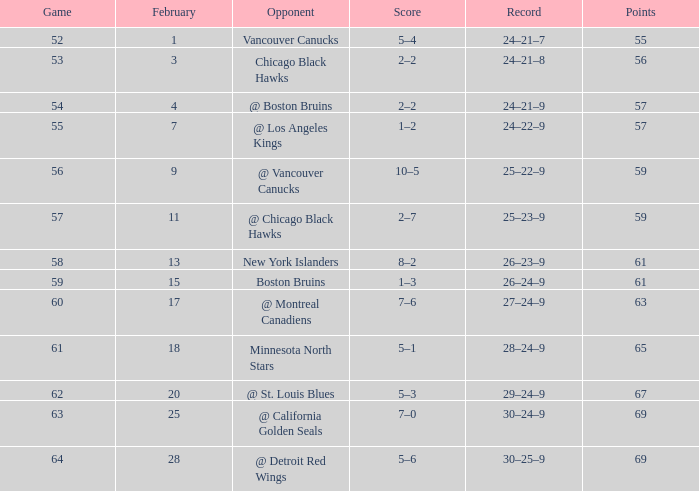How many games in february had a 29-24-9 record? 20.0. 